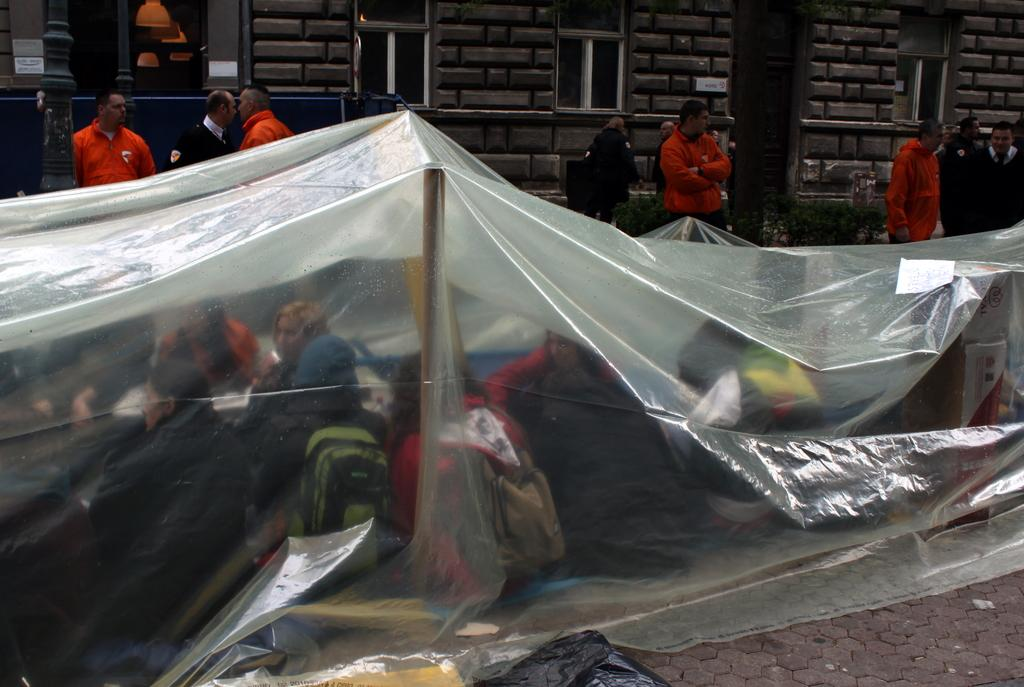How many people are in the image? There are people in the image, but the exact number is not specified. What are some people doing in the image? Some people are sitting under a cover in the image. What items are some people carrying in the image? Some people are wearing backpacks in the image. What architectural features can be seen in the image? There are windows, a pole, and a wall visible in the image. What type of glove is being used to clean the windows in the image? There is no glove present in the image, nor is there any indication that the windows are being cleaned. What type of fowl can be seen perched on the pole in the image? There is no fowl present in the image; only people, a cover, backpacks, windows, a pole, and a wall are visible. 